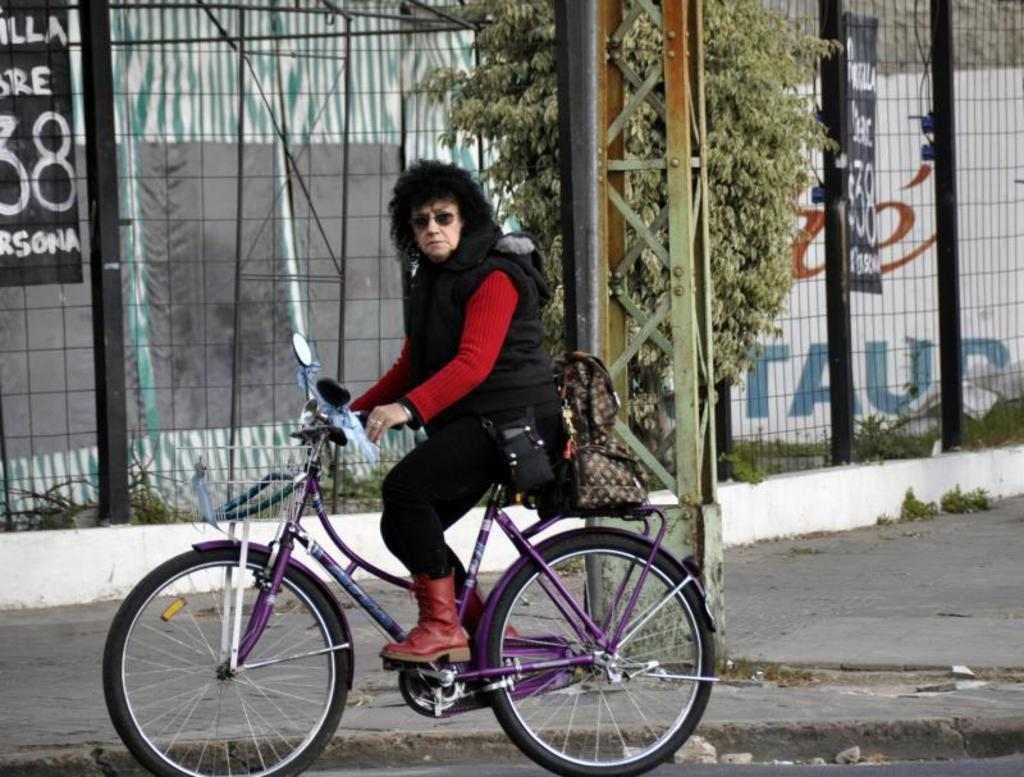Who is the main subject in the image? There is a woman in the image. What is the woman wearing? The woman is wearing a black jacket. What activity is the woman engaged in? The woman is riding a bicycle. What can be seen in the background of the image? There is a black fence in the image. What type of vegetation is near the woman? There is a tree beside the woman. Can you tell me what type of animal is sitting on the judge's lap in the image? There is no animal or judge present in the image; it features a woman riding a bicycle. 